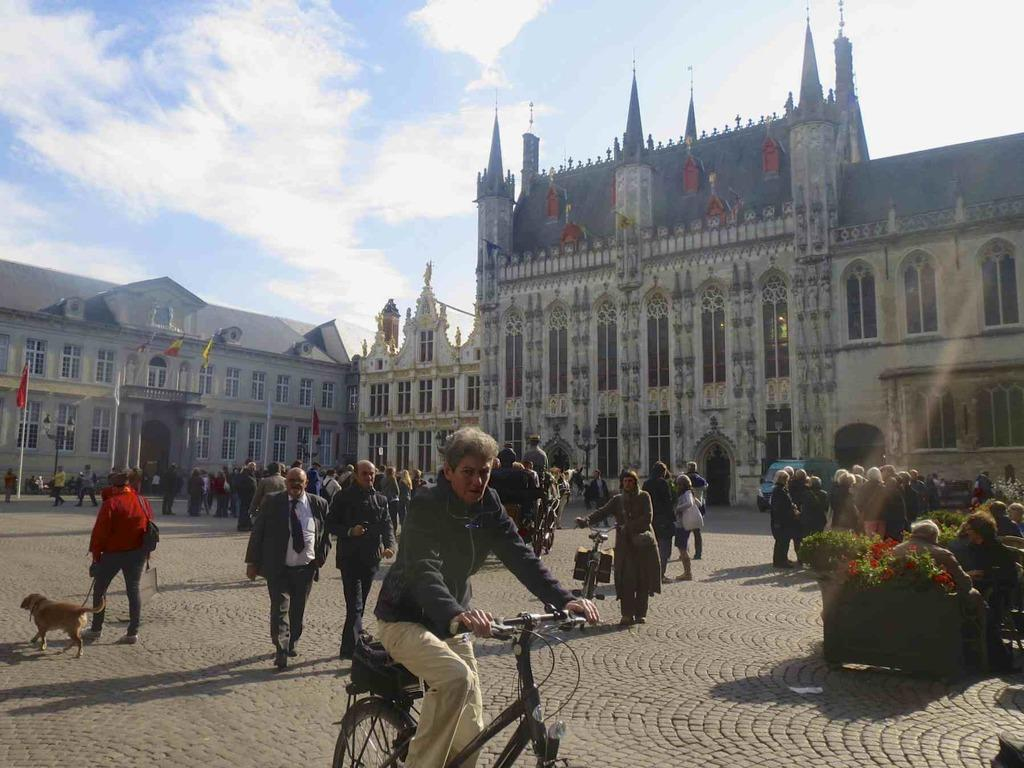What is the man in the image doing? The man is riding a bicycle in the image. What are the people in the image doing? People are walking in the image. What else is walking in the image besides people? A dog is walking in the image. What can be seen in the background of the image? There is a building in the image. What is the weather like in the image? It is a sunny day in the image. How much honey is the dog carrying in the image? There is no honey present in the image, and the dog is not carrying anything. What expertise does the man riding the bicycle have in the image? There is no indication of any expertise in the image; the man is simply riding a bicycle. 